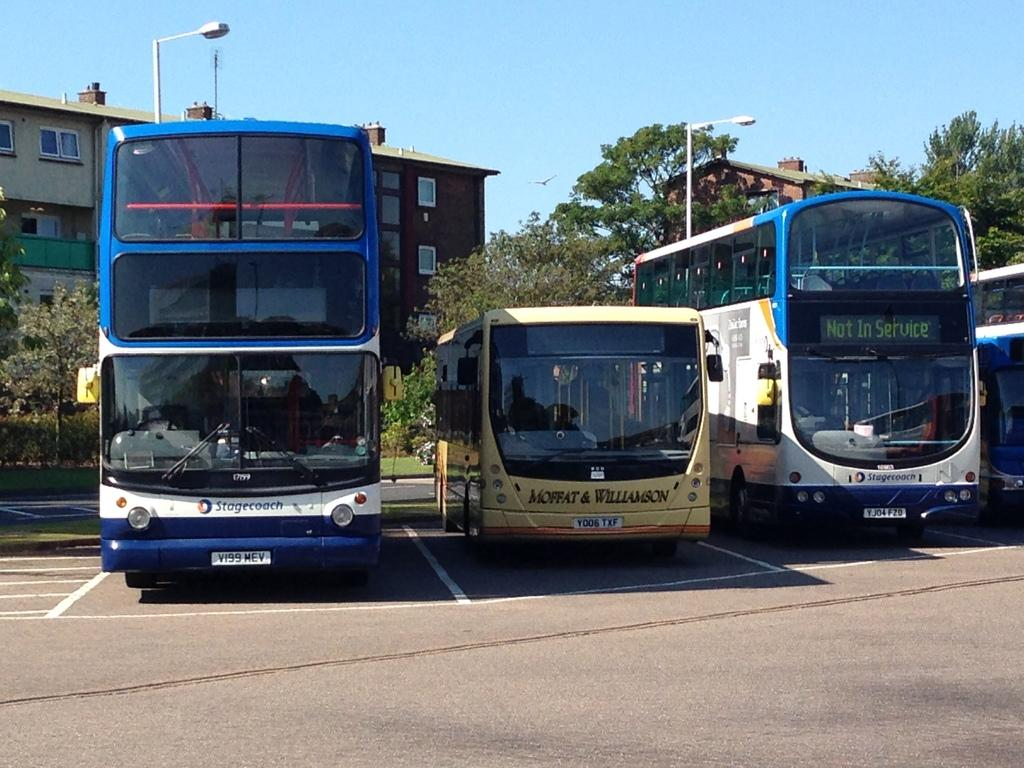What type of view is shown in the image? The image is an outside view. What can be seen on the road in the image? There are buses on the road in the image. What is visible in the background of the image? There are buildings, trees, and light poles in the background of the image. What is visible at the top of the image? The sky is visible at the top of the image. What type of songs can be heard playing from the buildings in the image? There is no indication of any songs being played in the image; it only shows buses, buildings, trees, light poles, and the sky. What type of powder is visible on the trees in the image? There is no powder visible on the trees in the image; it only shows trees, along with other elements mentioned in the facts. 